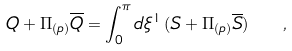Convert formula to latex. <formula><loc_0><loc_0><loc_500><loc_500>Q + \Pi _ { ( p ) } { \overline { Q } } = \int _ { 0 } ^ { \pi } d \xi ^ { 1 } \, ( S + \Pi _ { ( p ) } { \overline { S } } ) \ \ ,</formula> 